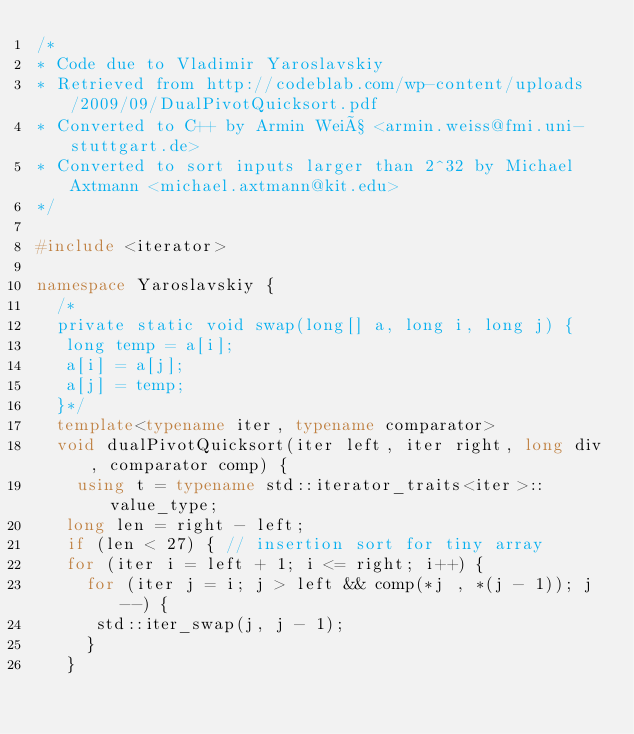<code> <loc_0><loc_0><loc_500><loc_500><_C++_>/*
* Code due to Vladimir Yaroslavskiy
* Retrieved from http://codeblab.com/wp-content/uploads/2009/09/DualPivotQuicksort.pdf
* Converted to C++ by Armin Weiß <armin.weiss@fmi.uni-stuttgart.de>
* Converted to sort inputs larger than 2^32 by Michael Axtmann <michael.axtmann@kit.edu>
*/

#include <iterator>

namespace Yaroslavskiy {
	/*
	private static void swap(long[] a, long i, long j) {
	 long temp = a[i];
	 a[i] = a[j];
	 a[j] = temp;
	}*/
  template<typename iter, typename comparator>
  void dualPivotQuicksort(iter left, iter right, long div, comparator comp) {
    using t = typename std::iterator_traits<iter>::value_type;
	 long len = right - left;
	 if (len < 27) { // insertion sort for tiny array
	 for (iter i = left + 1; i <= right; i++) {
		 for (iter j = i; j > left && comp(*j , *(j - 1)); j--) {
			std::iter_swap(j, j - 1);
		 }
	 }</code> 